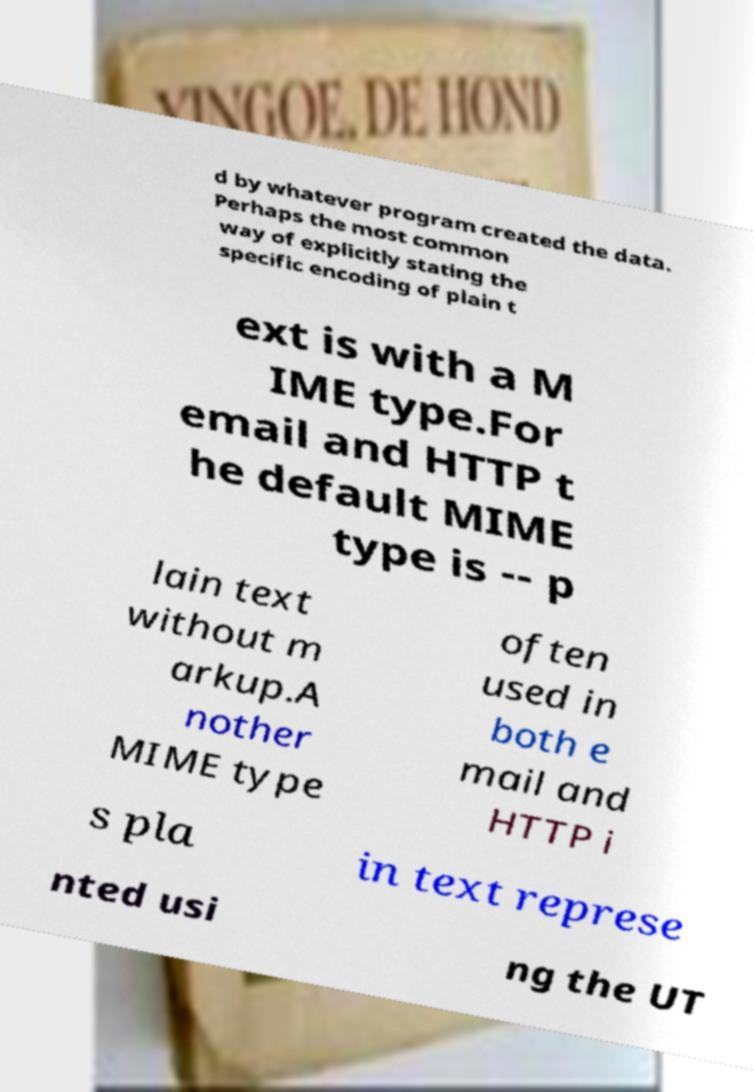Could you assist in decoding the text presented in this image and type it out clearly? d by whatever program created the data. Perhaps the most common way of explicitly stating the specific encoding of plain t ext is with a M IME type.For email and HTTP t he default MIME type is -- p lain text without m arkup.A nother MIME type often used in both e mail and HTTP i s pla in text represe nted usi ng the UT 